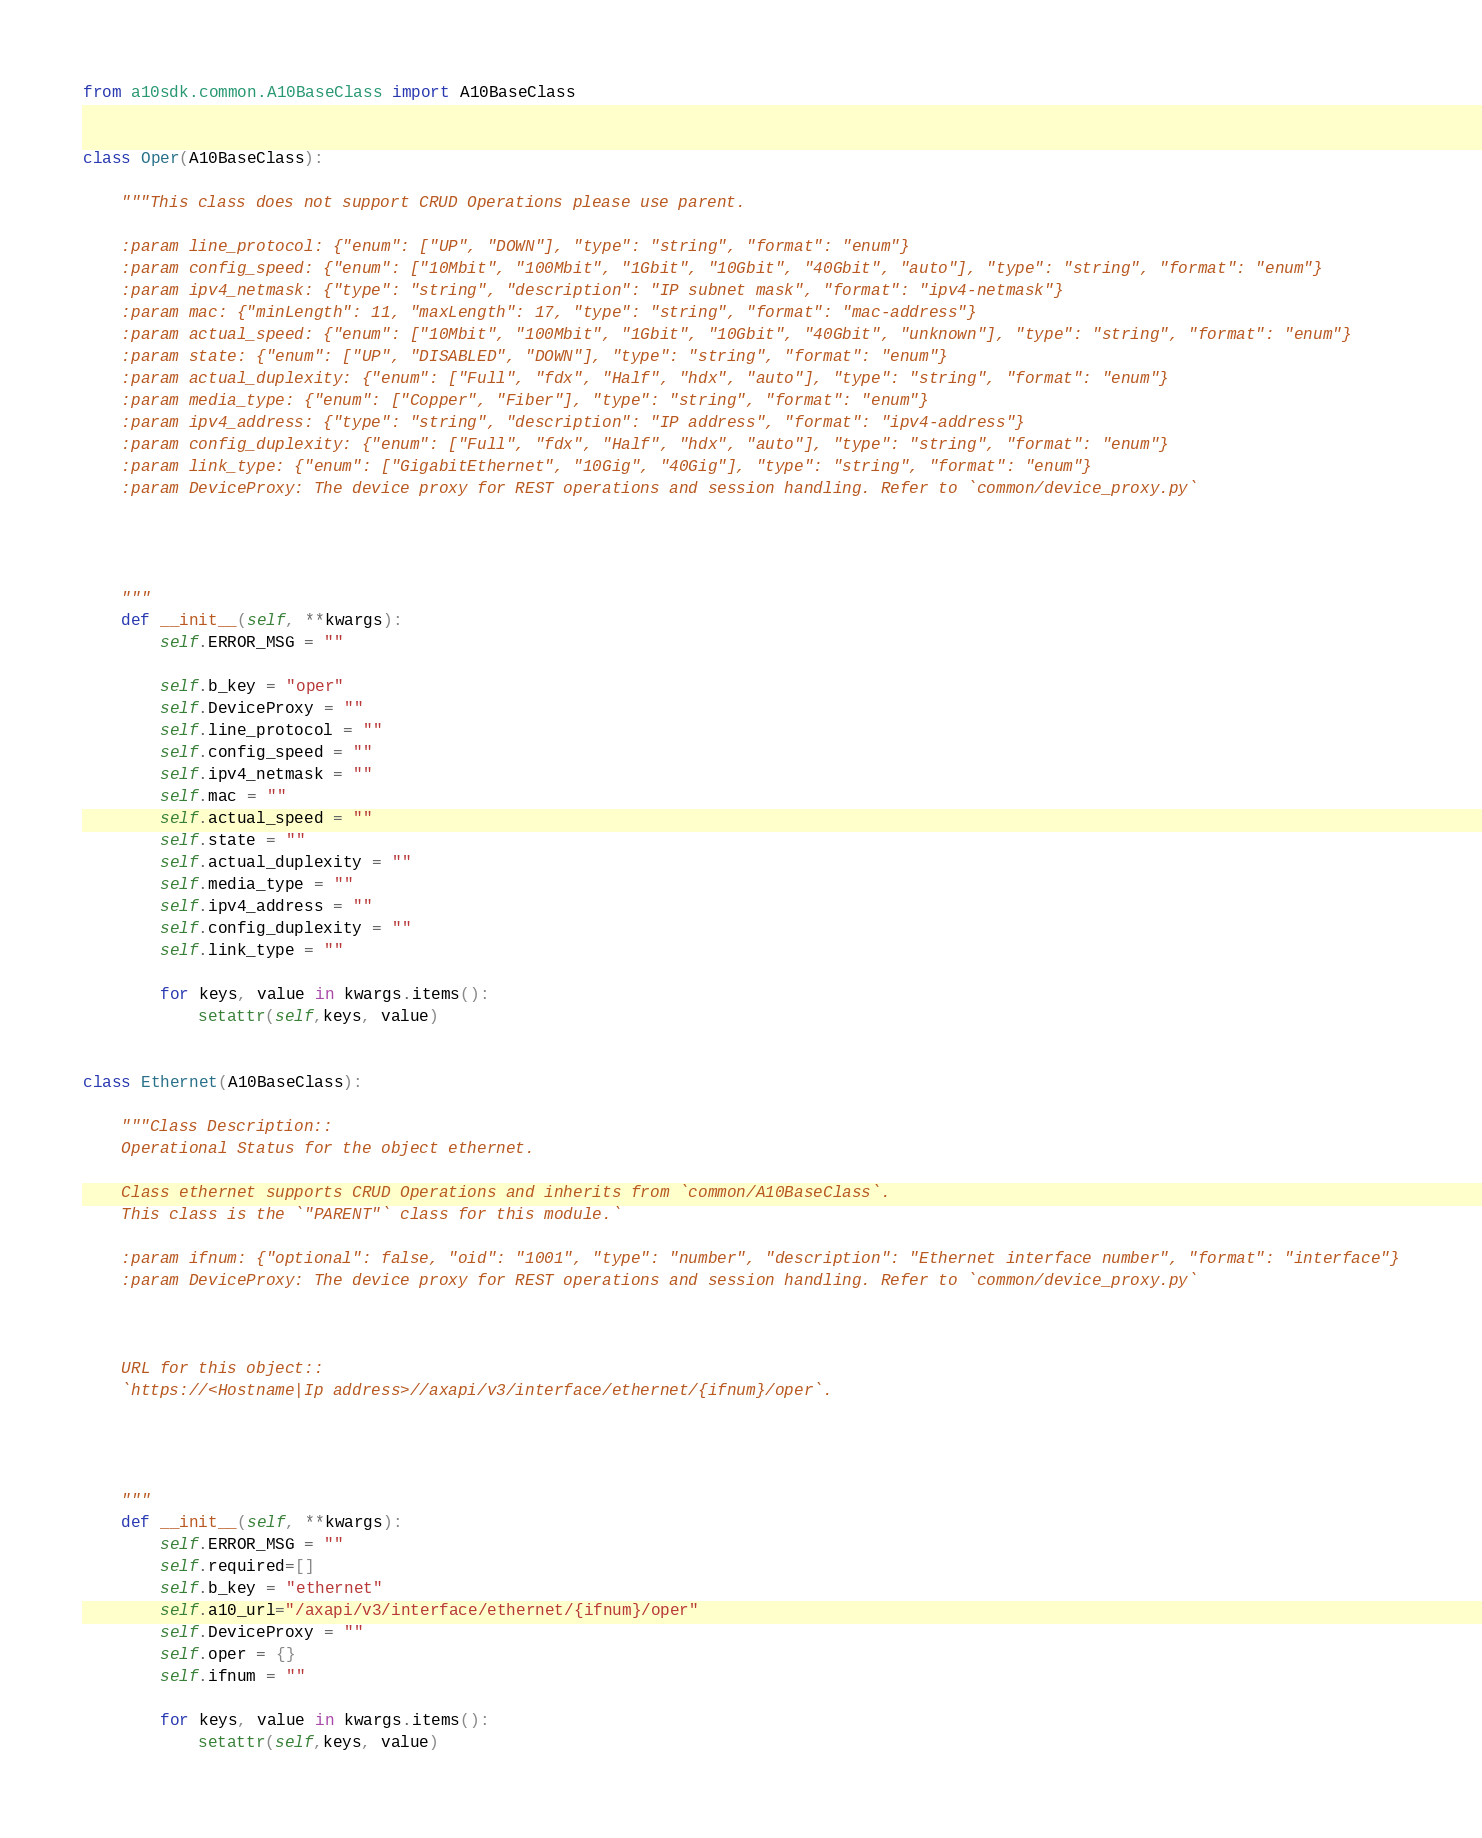<code> <loc_0><loc_0><loc_500><loc_500><_Python_>from a10sdk.common.A10BaseClass import A10BaseClass


class Oper(A10BaseClass):
    
    """This class does not support CRUD Operations please use parent.

    :param line_protocol: {"enum": ["UP", "DOWN"], "type": "string", "format": "enum"}
    :param config_speed: {"enum": ["10Mbit", "100Mbit", "1Gbit", "10Gbit", "40Gbit", "auto"], "type": "string", "format": "enum"}
    :param ipv4_netmask: {"type": "string", "description": "IP subnet mask", "format": "ipv4-netmask"}
    :param mac: {"minLength": 11, "maxLength": 17, "type": "string", "format": "mac-address"}
    :param actual_speed: {"enum": ["10Mbit", "100Mbit", "1Gbit", "10Gbit", "40Gbit", "unknown"], "type": "string", "format": "enum"}
    :param state: {"enum": ["UP", "DISABLED", "DOWN"], "type": "string", "format": "enum"}
    :param actual_duplexity: {"enum": ["Full", "fdx", "Half", "hdx", "auto"], "type": "string", "format": "enum"}
    :param media_type: {"enum": ["Copper", "Fiber"], "type": "string", "format": "enum"}
    :param ipv4_address: {"type": "string", "description": "IP address", "format": "ipv4-address"}
    :param config_duplexity: {"enum": ["Full", "fdx", "Half", "hdx", "auto"], "type": "string", "format": "enum"}
    :param link_type: {"enum": ["GigabitEthernet", "10Gig", "40Gig"], "type": "string", "format": "enum"}
    :param DeviceProxy: The device proxy for REST operations and session handling. Refer to `common/device_proxy.py`

    

    
    """
    def __init__(self, **kwargs):
        self.ERROR_MSG = ""
        
        self.b_key = "oper"
        self.DeviceProxy = ""
        self.line_protocol = ""
        self.config_speed = ""
        self.ipv4_netmask = ""
        self.mac = ""
        self.actual_speed = ""
        self.state = ""
        self.actual_duplexity = ""
        self.media_type = ""
        self.ipv4_address = ""
        self.config_duplexity = ""
        self.link_type = ""

        for keys, value in kwargs.items():
            setattr(self,keys, value)


class Ethernet(A10BaseClass):
    
    """Class Description::
    Operational Status for the object ethernet.

    Class ethernet supports CRUD Operations and inherits from `common/A10BaseClass`.
    This class is the `"PARENT"` class for this module.`

    :param ifnum: {"optional": false, "oid": "1001", "type": "number", "description": "Ethernet interface number", "format": "interface"}
    :param DeviceProxy: The device proxy for REST operations and session handling. Refer to `common/device_proxy.py`

    

    URL for this object::
    `https://<Hostname|Ip address>//axapi/v3/interface/ethernet/{ifnum}/oper`.

    

    
    """
    def __init__(self, **kwargs):
        self.ERROR_MSG = ""
        self.required=[]
        self.b_key = "ethernet"
        self.a10_url="/axapi/v3/interface/ethernet/{ifnum}/oper"
        self.DeviceProxy = ""
        self.oper = {}
        self.ifnum = ""

        for keys, value in kwargs.items():
            setattr(self,keys, value)


</code> 